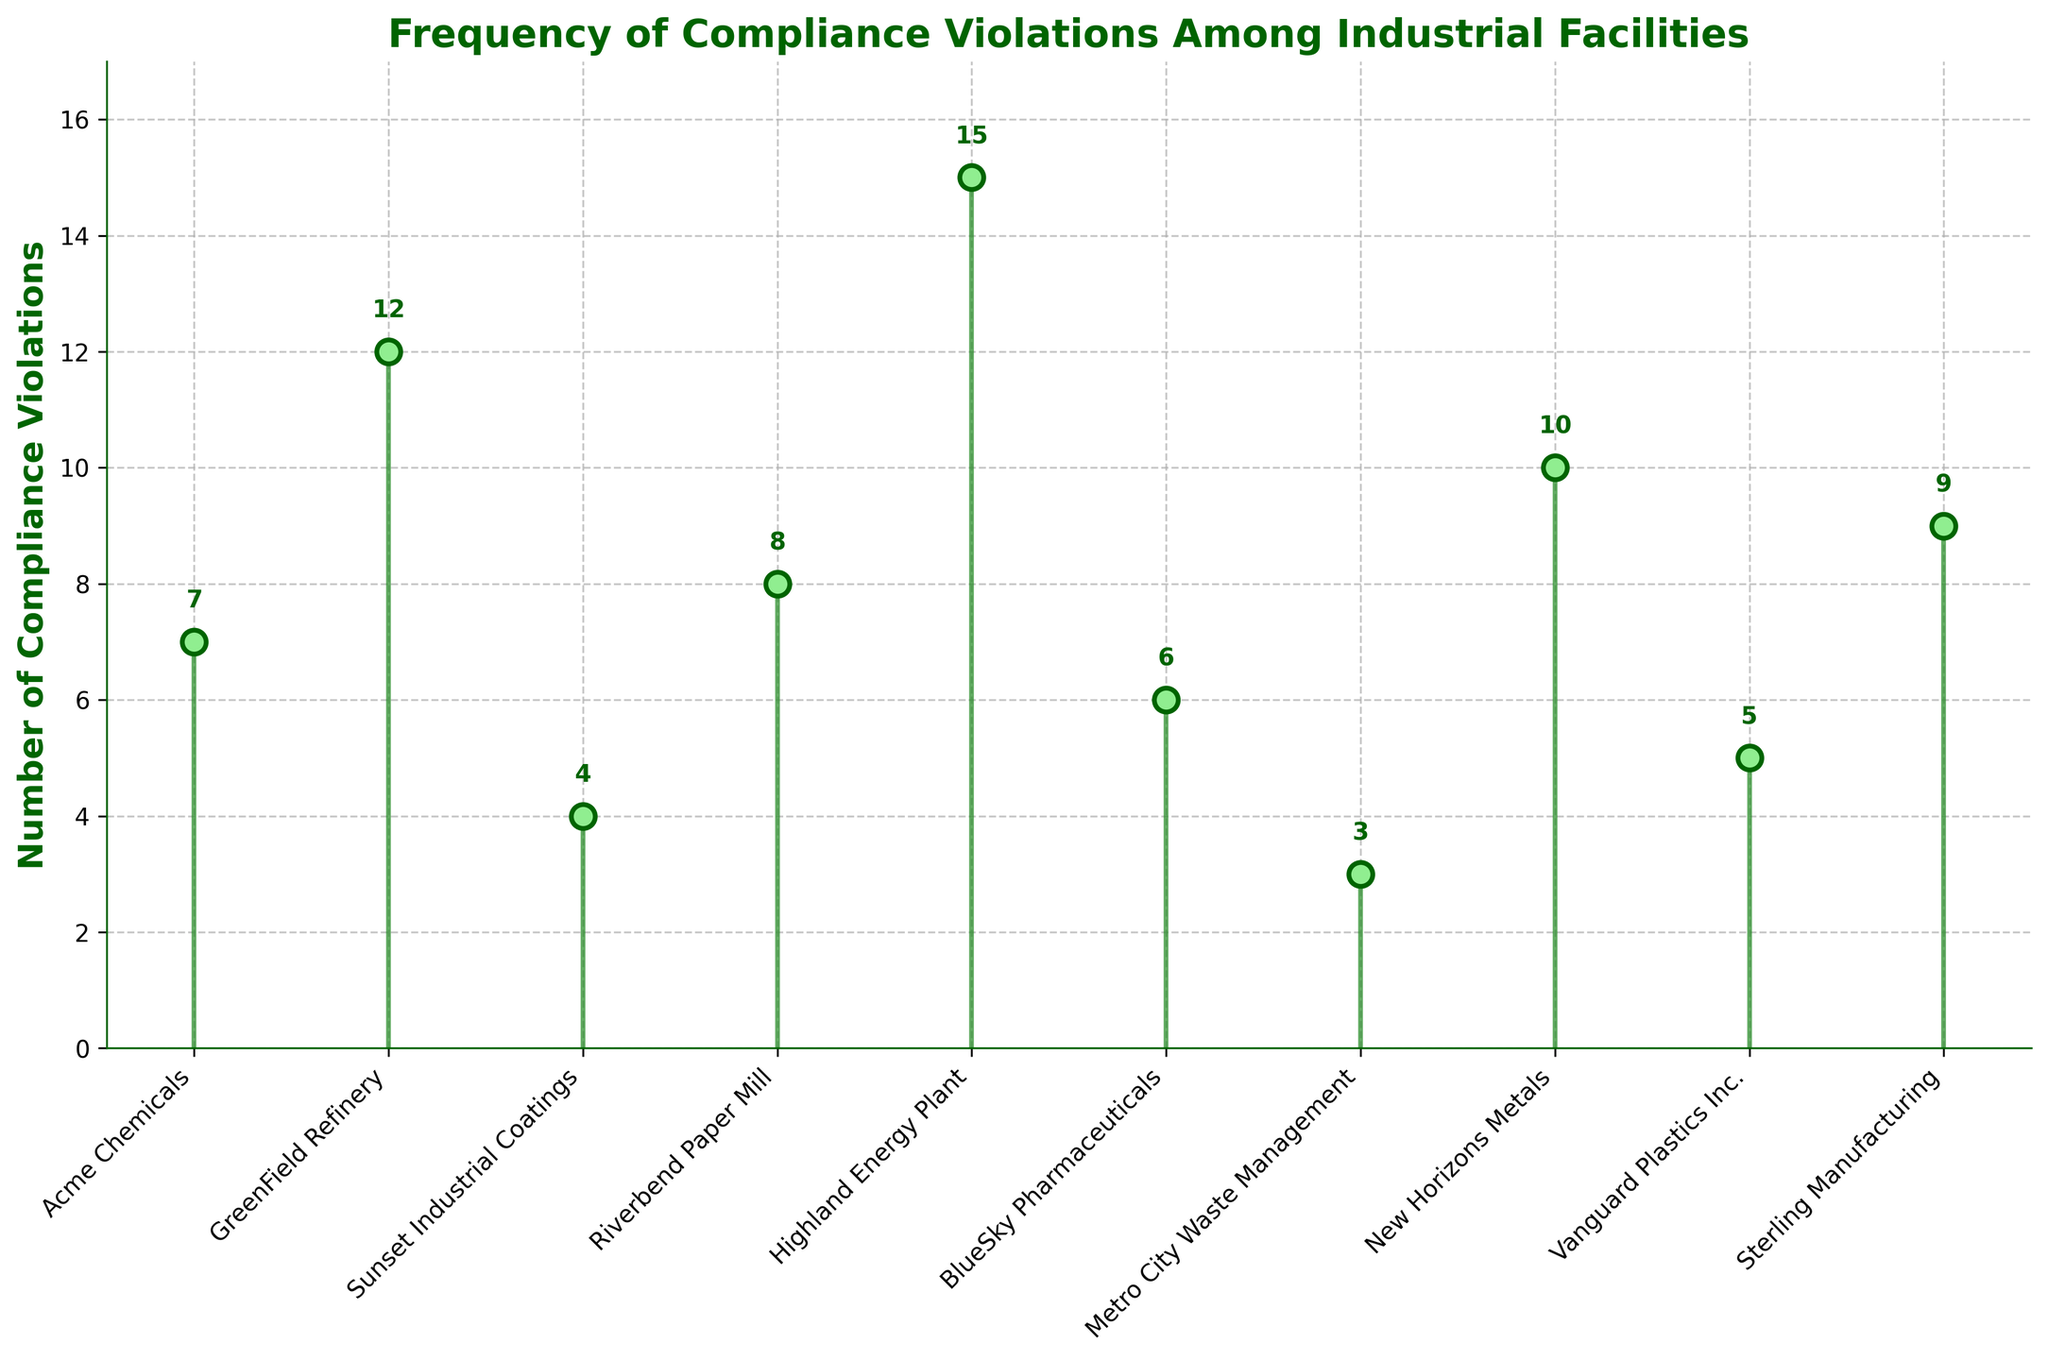What is the title of the figure? The title is displayed at the top of the figure.
Answer: Frequency of Compliance Violations Among Industrial Facilities Which facility has the highest number of compliance violations? By observing the height of the stem lines, Highland Energy Plant has the tallest line, indicating the highest number.
Answer: Highland Energy Plant What do the y-axis and x-axis represent? The y-axis shows the number of compliance violations, and the x-axis lists the names of the facilities.
Answer: The y-axis represents 'Number of Compliance Violations,' and the x-axis represents 'Facility names.' How many facilities have 7 or more compliance violations? By counting the stem lines with a value of 7 or higher, we can identify the facilities that meet this criterion.
Answer: 6 facilities What is the average number of compliance violations among all the facilities? Adding the number of violations and dividing by the number of facilities: (7+12+4+8+15+6+3+10+5+9)/10
Answer: 7.9 Which facility has the fewest compliance violations and how many? By examining the shortest stem line, Metro City Waste Management has the fewest violations.
Answer: Metro City Waste Management with 3 violations What is the difference in compliance violations between GreenField Refinery and Vanguard Plastics Inc.? Subtract the number of violations of Vanguard Plastics Inc. from GreenField Refinery: 12 - 5
Answer: 7 How many facilities have compliance violations greater than 5 but less than 10? Counting the stem lines within the range (6 to 9 inclusive): Acme Chemicals, Riverbend Paper Mill, BlueSky Pharmaceuticals, and Sterling Manufacturing.
Answer: 4 facilities Which two facilities have a close number of compliance violations and what are those numbers? By identifying closely spaced stem lines, Acme Chemicals and BlueSky Pharmaceuticals have values close to each other: 7 and 6.
Answer: Acme Chemicals (7), BlueSky Pharmaceuticals (6) What is the median number of compliance violations? Sorting violations in ascending order (3, 4, 5, 6, 7, 8, 9, 10, 12, 15), the middle two values are 7 and 8. The median is the average of these: (7+8)/2
Answer: 7.5 